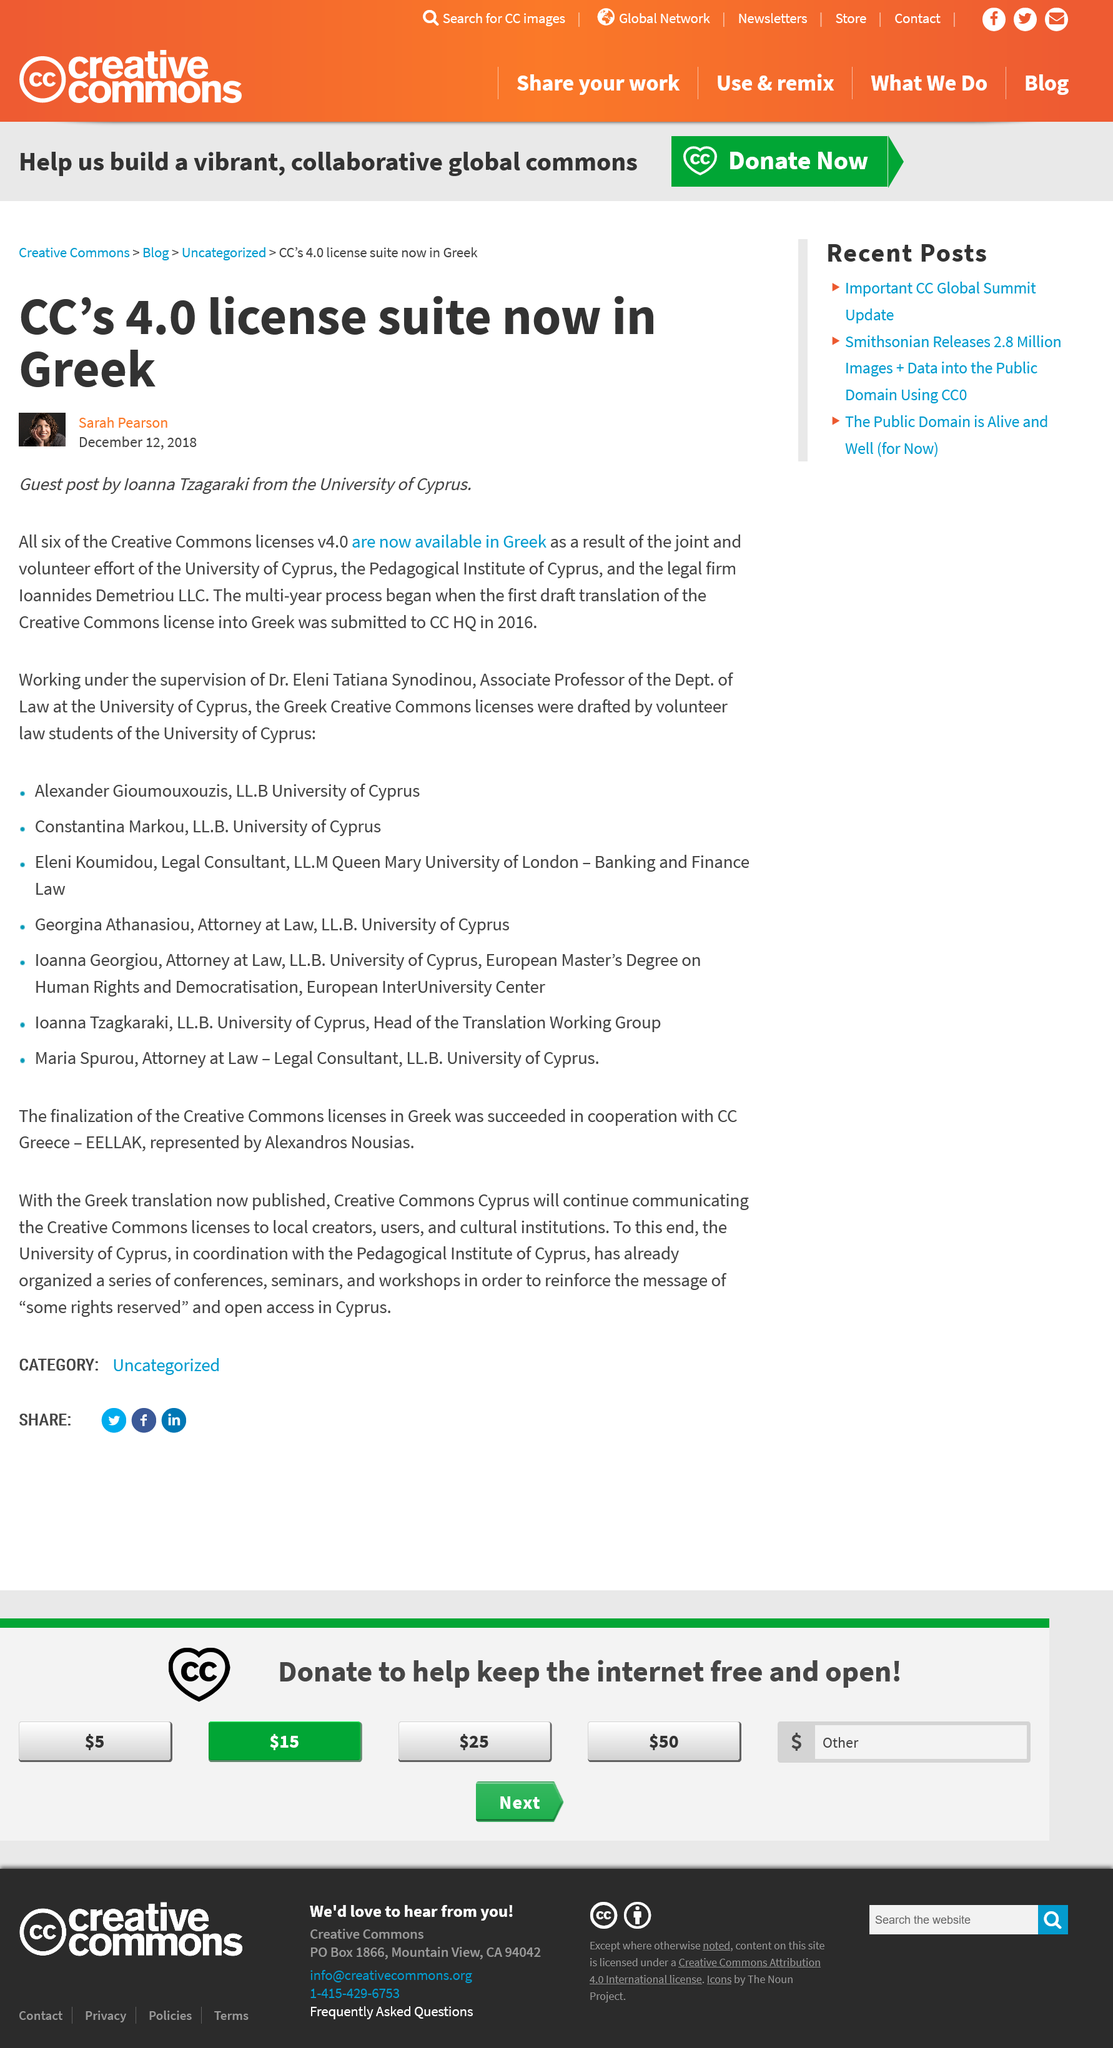List a handful of essential elements in this visual. Six (6) of the Creative Commons licenses available under v4.0 are now available in Greek. The name of the person depicted in the small portrait under the title is Sarah Pearson. The University of Cyprus drafted the Greek Creative Commons licenses, which were created by volunteer law students. 